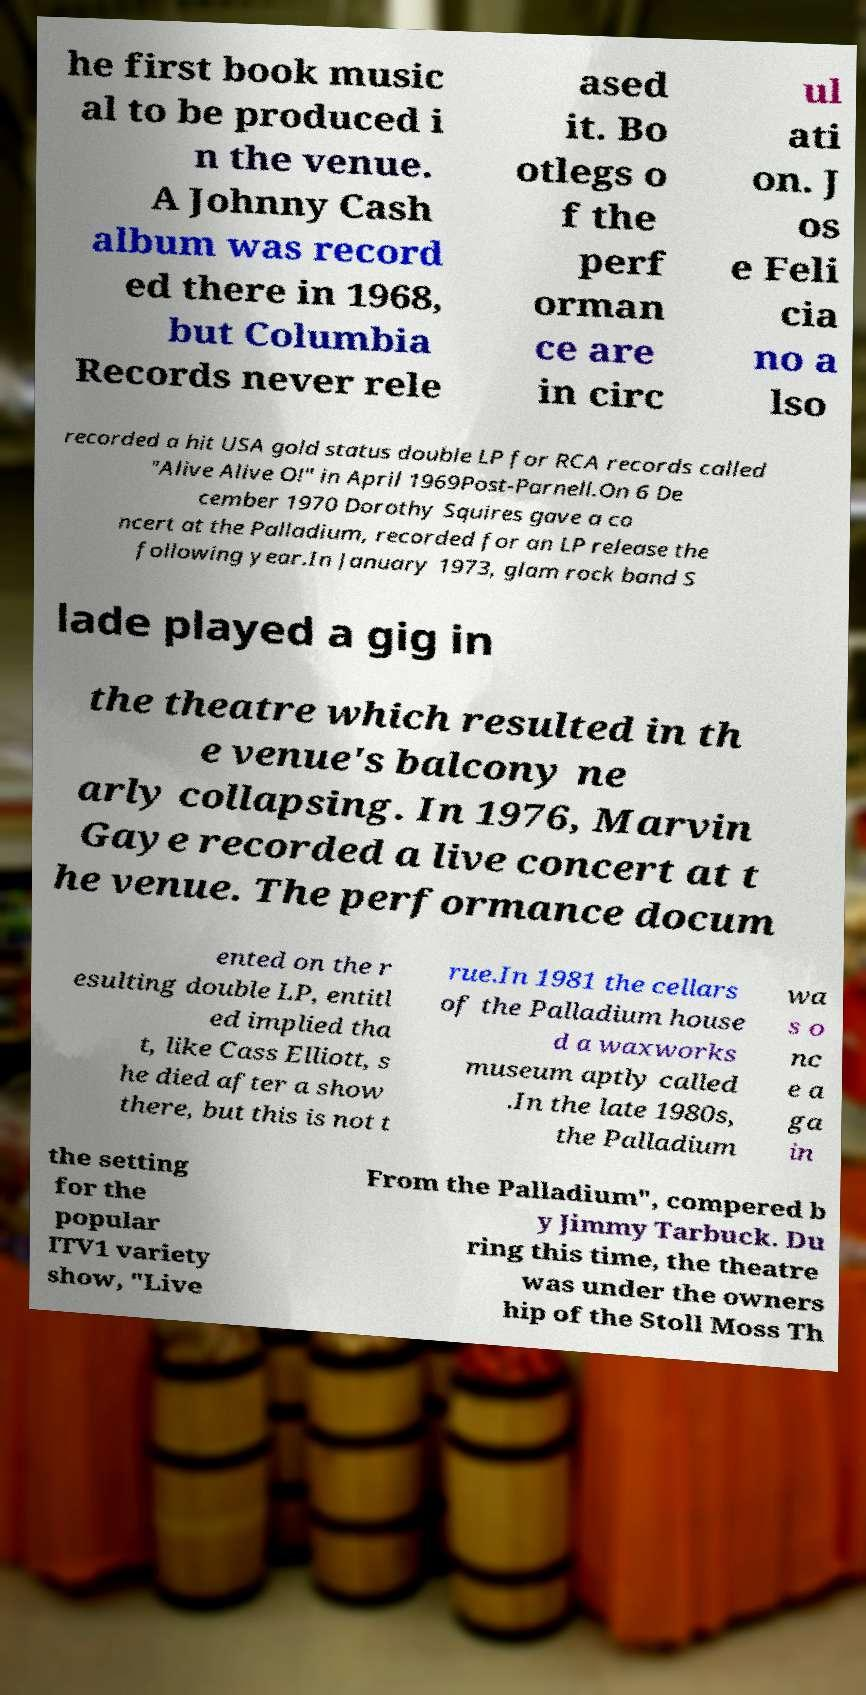Please read and relay the text visible in this image. What does it say? he first book music al to be produced i n the venue. A Johnny Cash album was record ed there in 1968, but Columbia Records never rele ased it. Bo otlegs o f the perf orman ce are in circ ul ati on. J os e Feli cia no a lso recorded a hit USA gold status double LP for RCA records called "Alive Alive O!" in April 1969Post-Parnell.On 6 De cember 1970 Dorothy Squires gave a co ncert at the Palladium, recorded for an LP release the following year.In January 1973, glam rock band S lade played a gig in the theatre which resulted in th e venue's balcony ne arly collapsing. In 1976, Marvin Gaye recorded a live concert at t he venue. The performance docum ented on the r esulting double LP, entitl ed implied tha t, like Cass Elliott, s he died after a show there, but this is not t rue.In 1981 the cellars of the Palladium house d a waxworks museum aptly called .In the late 1980s, the Palladium wa s o nc e a ga in the setting for the popular ITV1 variety show, "Live From the Palladium", compered b y Jimmy Tarbuck. Du ring this time, the theatre was under the owners hip of the Stoll Moss Th 